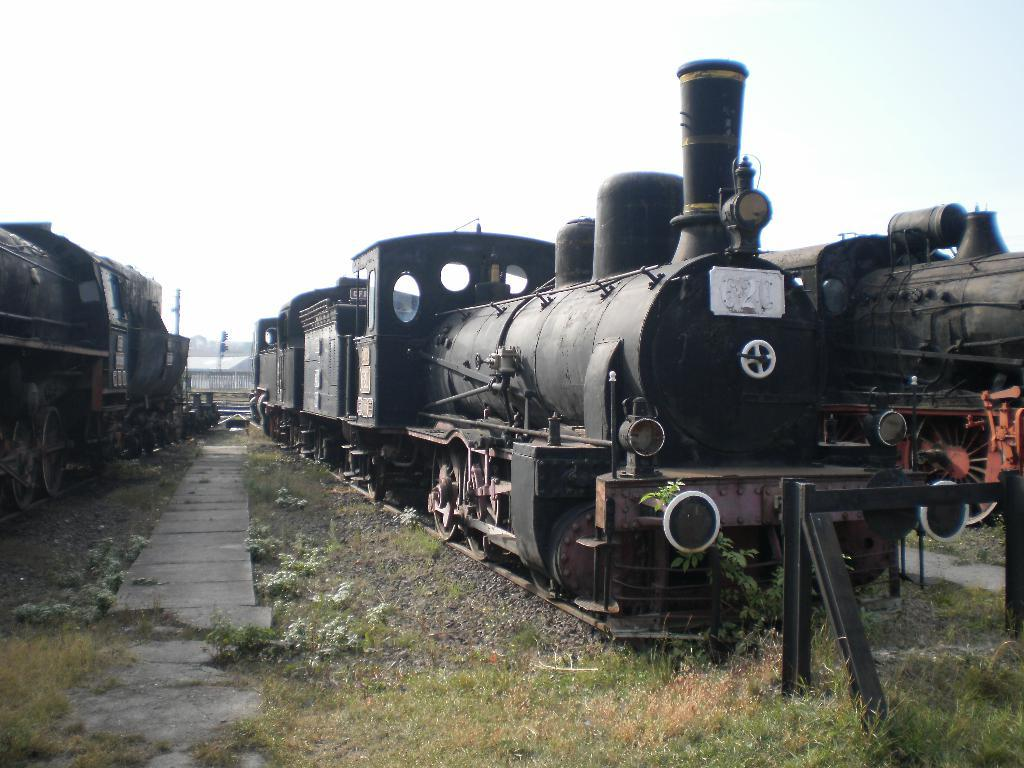What type of vehicles are present in the image? There are trains standing on the ground in the image. What else can be seen on the ground in the image? There are stones and grass on the ground in the image. What is visible in the sky in the image? The sky is clear and visible in the image. Where is the chessboard located in the image? There is no chessboard present in the image. What type of glue is being used to hold the stones together in the image? There is no glue or indication of stones being held together in the image. 